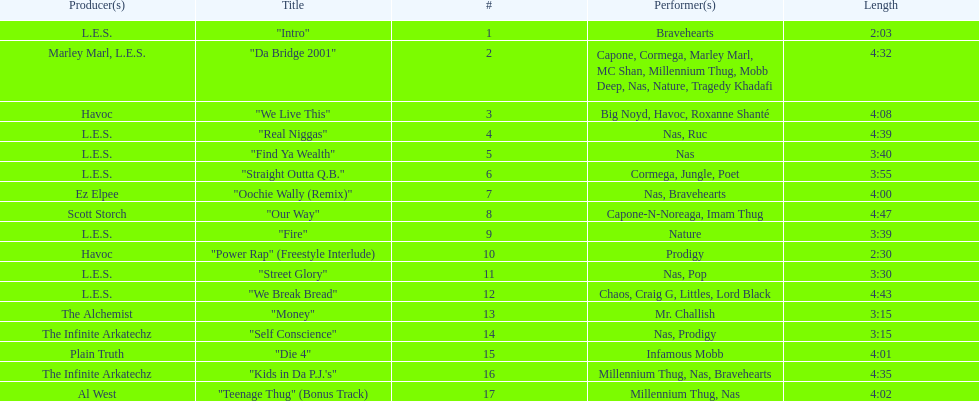What song was performed before "fire"? "Our Way". 